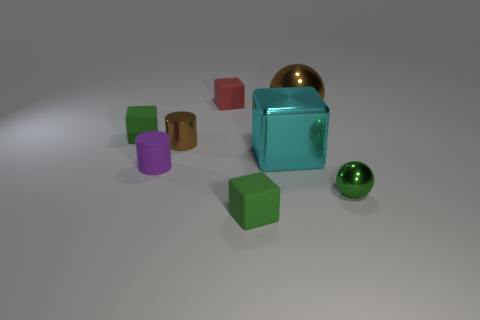What shape is the tiny green metallic thing?
Offer a terse response. Sphere. Are there any large shiny objects that have the same shape as the tiny red matte thing?
Provide a short and direct response. Yes. Are there more cyan shiny objects that are to the right of the big brown ball than purple matte things?
Your answer should be very brief. No. How many rubber objects are cyan cubes or cylinders?
Offer a very short reply. 1. There is a thing that is both in front of the small brown cylinder and on the left side of the tiny red thing; how big is it?
Offer a terse response. Small. There is a thing in front of the small metal sphere; is there a large cyan cube behind it?
Your response must be concise. Yes. There is a small green metallic ball; what number of shiny spheres are in front of it?
Offer a very short reply. 0. The other large metallic thing that is the same shape as the red thing is what color?
Your answer should be very brief. Cyan. Does the sphere that is behind the tiny brown metallic cylinder have the same material as the small object that is on the left side of the small purple cylinder?
Ensure brevity in your answer.  No. There is a small metal cylinder; does it have the same color as the large thing that is in front of the small brown metallic thing?
Your answer should be compact. No. 